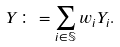<formula> <loc_0><loc_0><loc_500><loc_500>Y \colon = \sum _ { i \in \mathbb { S } } w _ { i } Y _ { i } .</formula> 